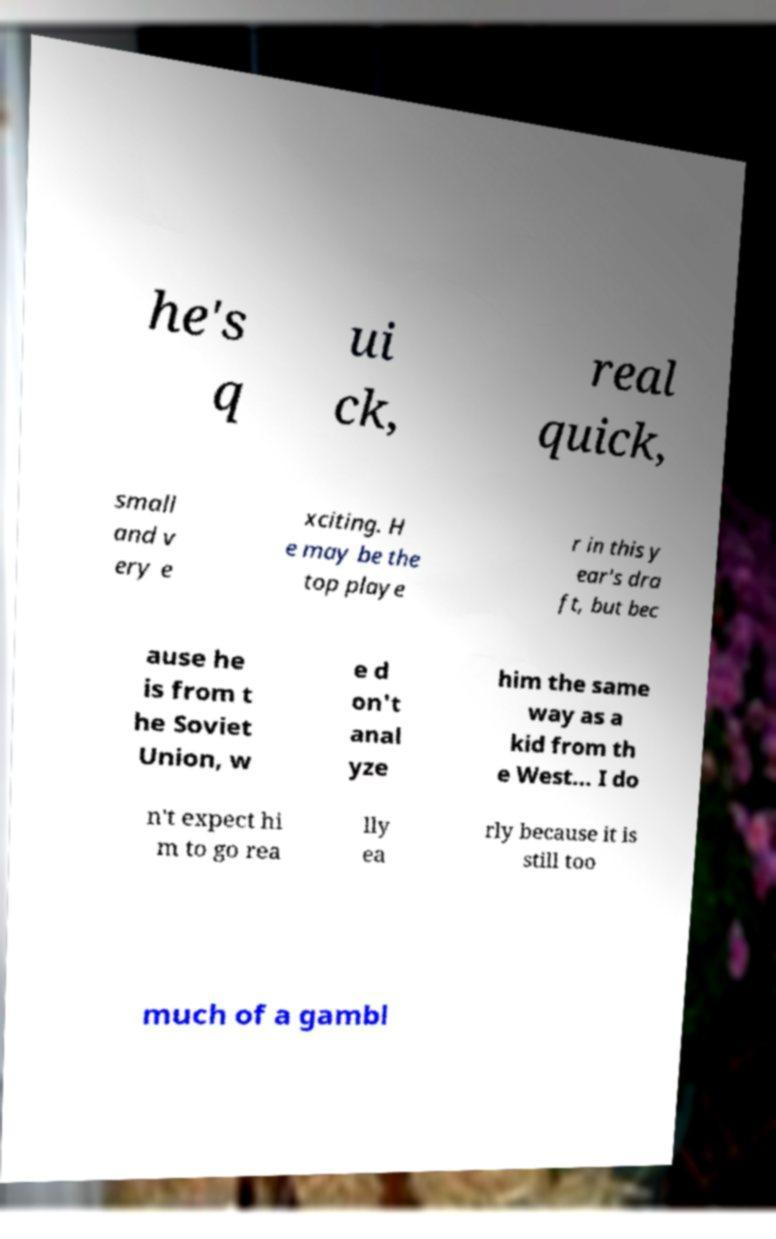What messages or text are displayed in this image? I need them in a readable, typed format. he's q ui ck, real quick, small and v ery e xciting. H e may be the top playe r in this y ear's dra ft, but bec ause he is from t he Soviet Union, w e d on't anal yze him the same way as a kid from th e West... I do n't expect hi m to go rea lly ea rly because it is still too much of a gambl 